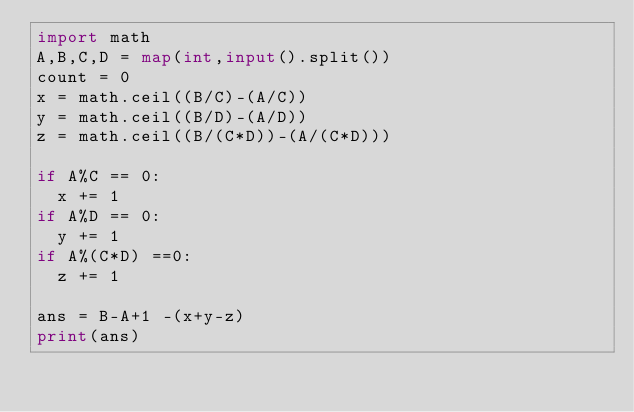<code> <loc_0><loc_0><loc_500><loc_500><_Python_>import math
A,B,C,D = map(int,input().split())
count = 0
x = math.ceil((B/C)-(A/C))
y = math.ceil((B/D)-(A/D))
z = math.ceil((B/(C*D))-(A/(C*D)))

if A%C == 0:
  x += 1
if A%D == 0:
  y += 1
if A%(C*D) ==0:
  z += 1

ans = B-A+1 -(x+y-z)
print(ans)</code> 